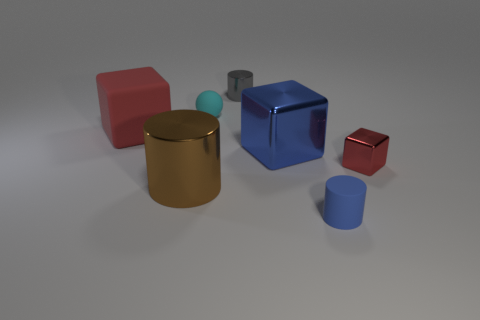Add 3 gray matte spheres. How many objects exist? 10 Subtract all spheres. How many objects are left? 6 Subtract 0 purple cylinders. How many objects are left? 7 Subtract all small cubes. Subtract all brown metallic objects. How many objects are left? 5 Add 4 blue cubes. How many blue cubes are left? 5 Add 7 large brown cylinders. How many large brown cylinders exist? 8 